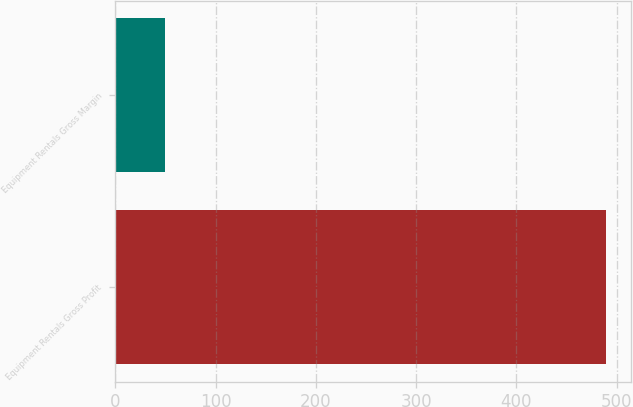Convert chart to OTSL. <chart><loc_0><loc_0><loc_500><loc_500><bar_chart><fcel>Equipment Rentals Gross Profit<fcel>Equipment Rentals Gross Margin<nl><fcel>490<fcel>49.6<nl></chart> 